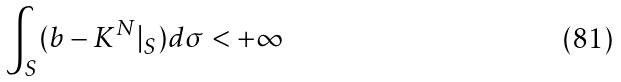<formula> <loc_0><loc_0><loc_500><loc_500>\int _ { S } ( b - K ^ { N } | _ { S } ) d \sigma < + \infty</formula> 